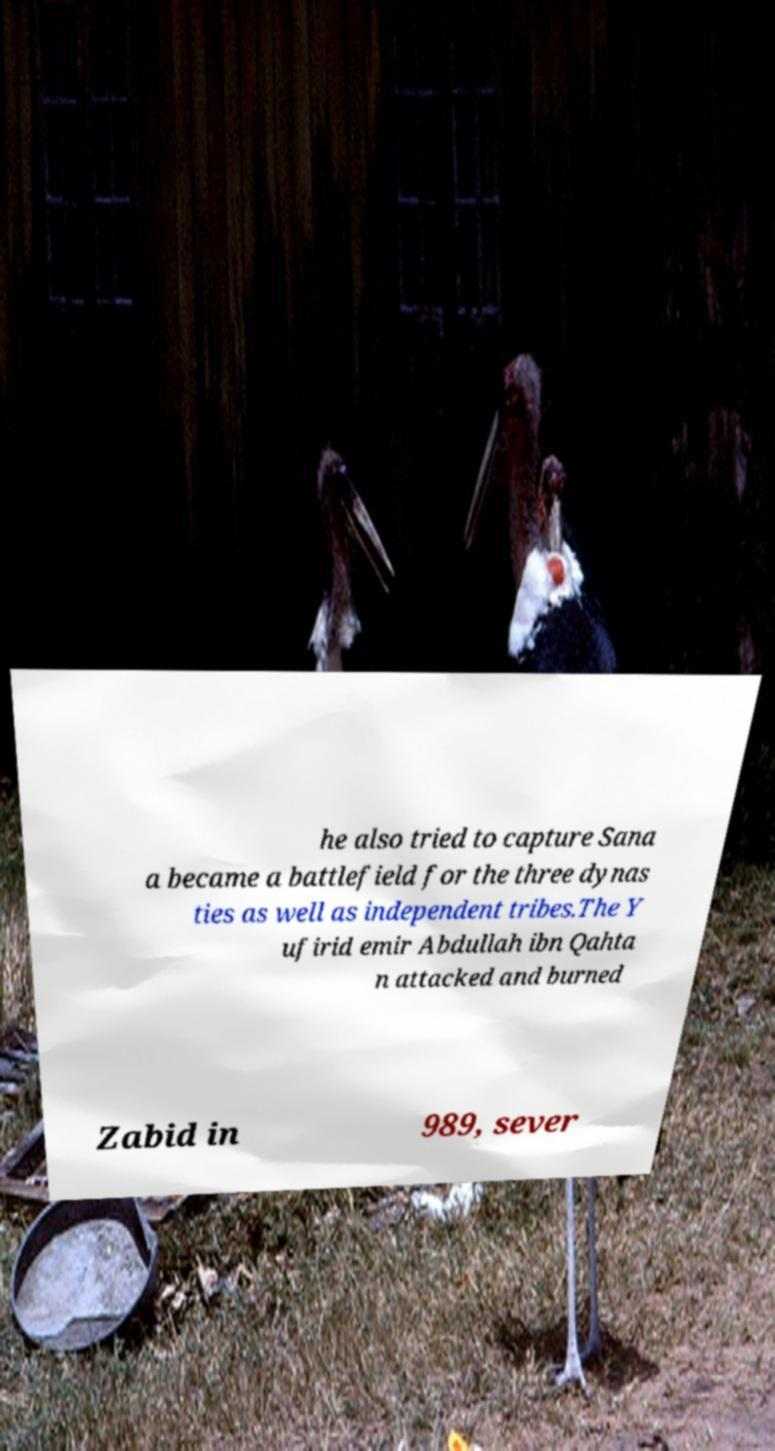Can you read and provide the text displayed in the image?This photo seems to have some interesting text. Can you extract and type it out for me? he also tried to capture Sana a became a battlefield for the three dynas ties as well as independent tribes.The Y ufirid emir Abdullah ibn Qahta n attacked and burned Zabid in 989, sever 